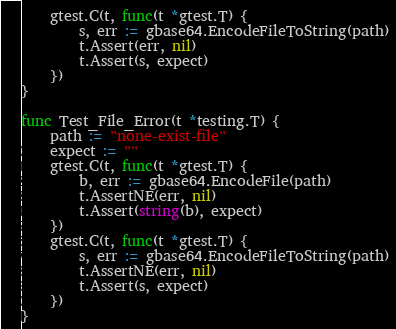<code> <loc_0><loc_0><loc_500><loc_500><_Go_>	gtest.C(t, func(t *gtest.T) {
		s, err := gbase64.EncodeFileToString(path)
		t.Assert(err, nil)
		t.Assert(s, expect)
	})
}

func Test_File_Error(t *testing.T) {
	path := "none-exist-file"
	expect := ""
	gtest.C(t, func(t *gtest.T) {
		b, err := gbase64.EncodeFile(path)
		t.AssertNE(err, nil)
		t.Assert(string(b), expect)
	})
	gtest.C(t, func(t *gtest.T) {
		s, err := gbase64.EncodeFileToString(path)
		t.AssertNE(err, nil)
		t.Assert(s, expect)
	})
}
</code> 